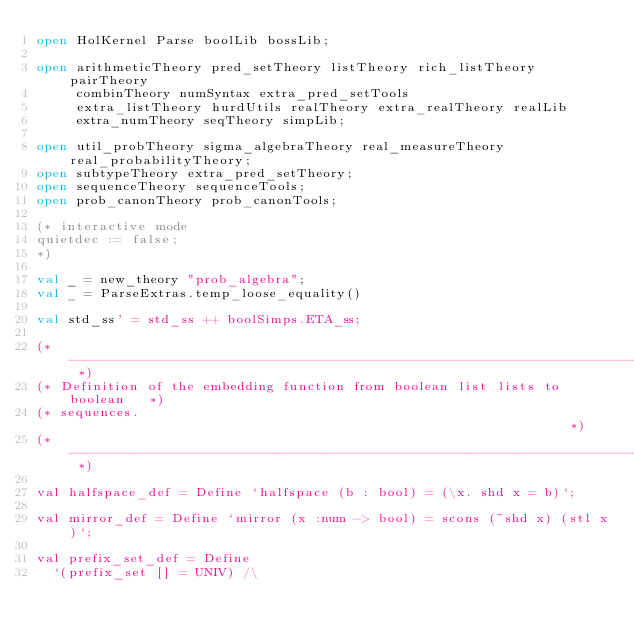<code> <loc_0><loc_0><loc_500><loc_500><_SML_>open HolKernel Parse boolLib bossLib;

open arithmeticTheory pred_setTheory listTheory rich_listTheory pairTheory
     combinTheory numSyntax extra_pred_setTools
     extra_listTheory hurdUtils realTheory extra_realTheory realLib
     extra_numTheory seqTheory simpLib;

open util_probTheory sigma_algebraTheory real_measureTheory real_probabilityTheory;
open subtypeTheory extra_pred_setTheory;
open sequenceTheory sequenceTools;
open prob_canonTheory prob_canonTools;

(* interactive mode
quietdec := false;
*)

val _ = new_theory "prob_algebra";
val _ = ParseExtras.temp_loose_equality()

val std_ss' = std_ss ++ boolSimps.ETA_ss;

(* ------------------------------------------------------------------------- *)
(* Definition of the embedding function from boolean list lists to boolean   *)
(* sequences.                                                                *)
(* ------------------------------------------------------------------------- *)

val halfspace_def = Define `halfspace (b : bool) = (\x. shd x = b)`;

val mirror_def = Define `mirror (x :num -> bool) = scons (~shd x) (stl x)`;

val prefix_set_def = Define
  `(prefix_set [] = UNIV) /\</code> 